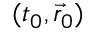Convert formula to latex. <formula><loc_0><loc_0><loc_500><loc_500>( t _ { 0 } , \vec { r } _ { 0 } )</formula> 